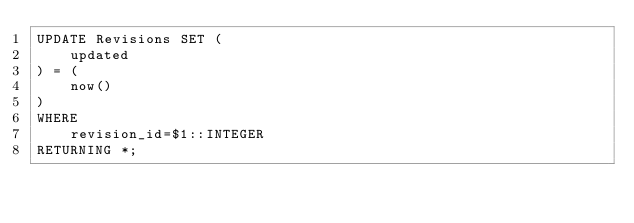<code> <loc_0><loc_0><loc_500><loc_500><_SQL_>UPDATE Revisions SET (
    updated
) = (
    now()
)
WHERE
    revision_id=$1::INTEGER
RETURNING *;
</code> 